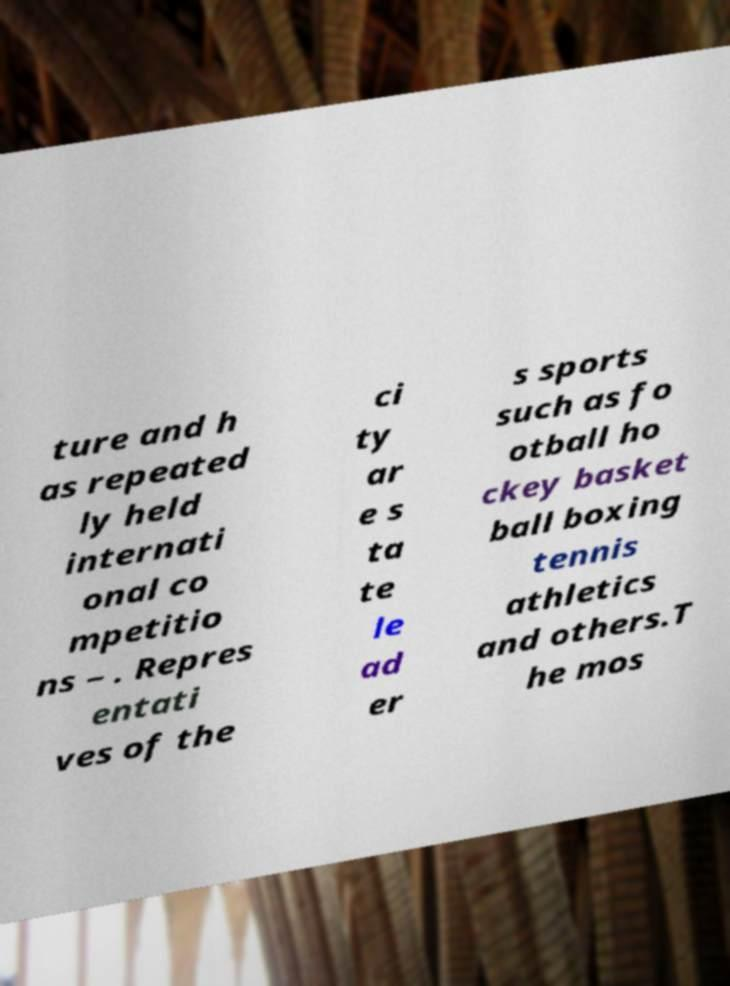For documentation purposes, I need the text within this image transcribed. Could you provide that? ture and h as repeated ly held internati onal co mpetitio ns – . Repres entati ves of the ci ty ar e s ta te le ad er s sports such as fo otball ho ckey basket ball boxing tennis athletics and others.T he mos 